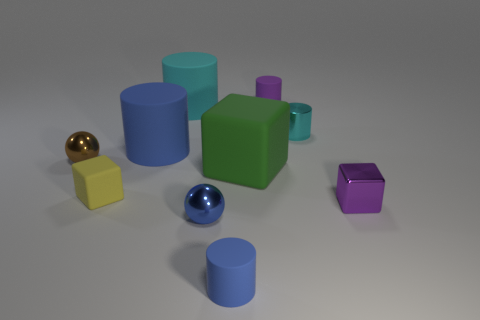There is a tiny purple thing that is the same shape as the large blue rubber thing; what material is it? rubber 